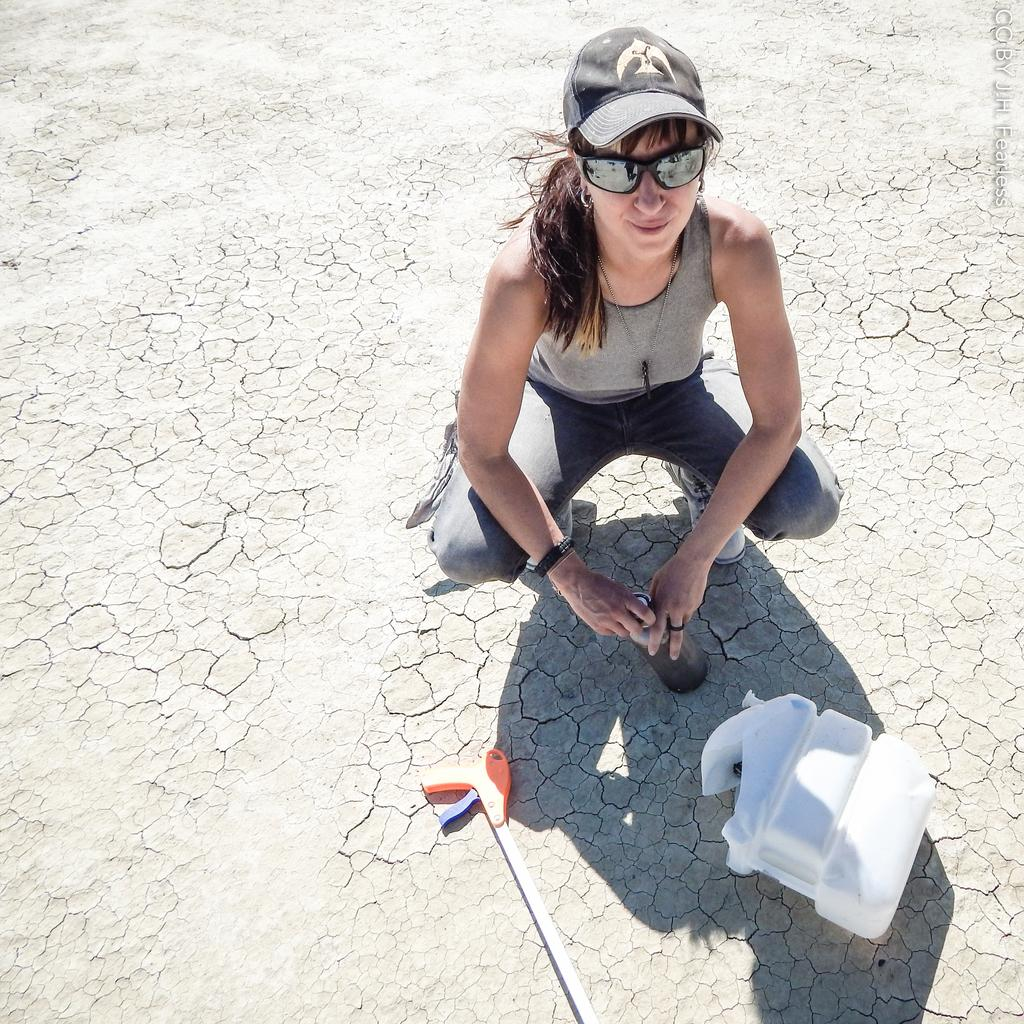Who is present in the image? There is a person in the image. What is the person wearing on their head? The person is wearing a cap. What is the person holding in their hand? The person is holding a bottle. What can be seen on the surface in the foreground of the image? There are objects on the surface in the foreground of the image. What type of meeting is taking place in the image? There is no meeting present in the image; it only features a person wearing a cap and holding a bottle. 